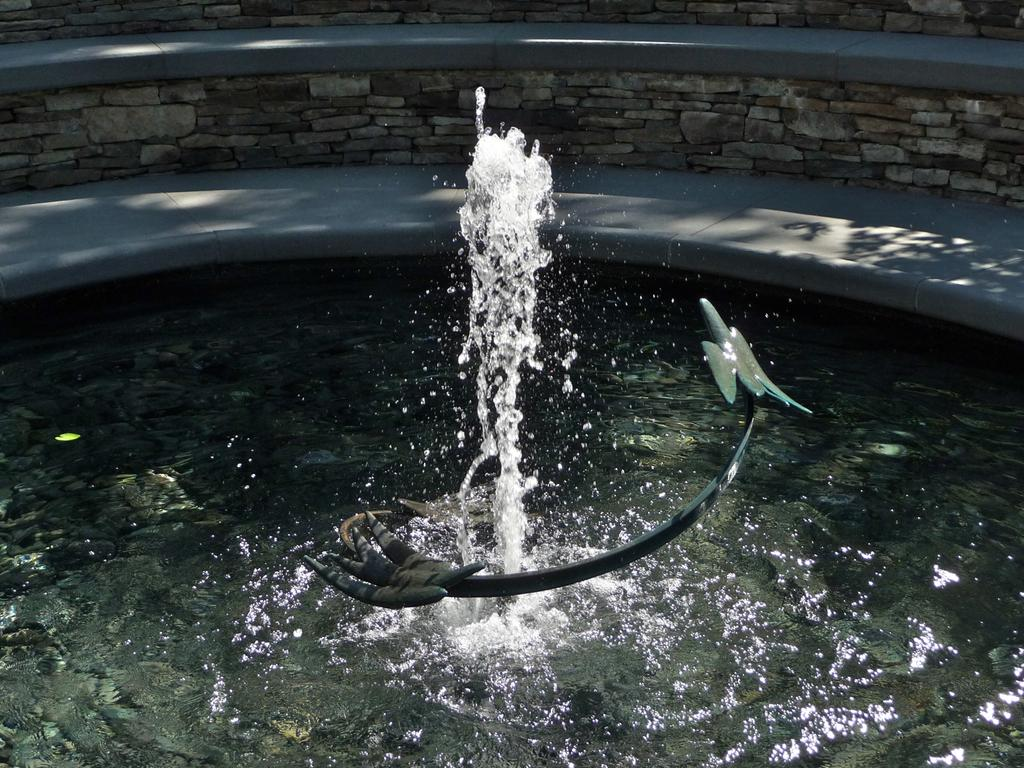What is the main feature in the image? There is a water fountain in the image. What can be seen in the foreground of the image? There is an object in the foreground of the image. What is visible at the bottom of the image? There is water visible at the bottom of the image. What type of structure is in the background of the image? There is a stone wall in the background of the image. How many windows are visible in the image? There are no windows visible in the image. What type of tool is being used to fix the patch in the image? There is no patch or tool present in the image. 